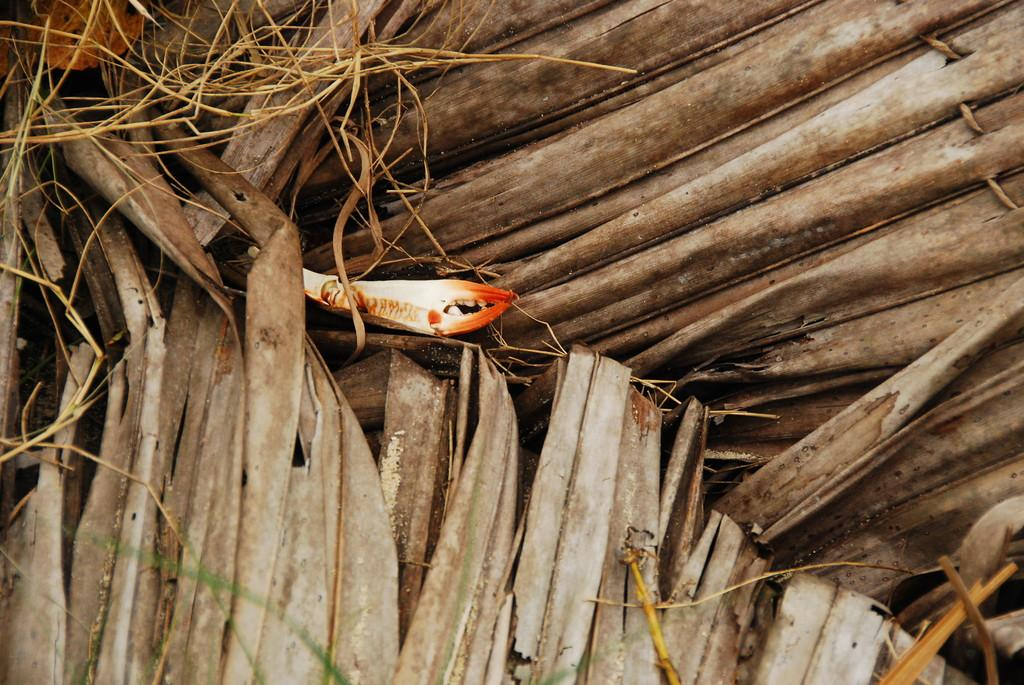What material is used to construct the roof in the image? The roof in the image is made of dry leaves. Can you describe the object located in the middle of the image? There is an orange and white color thing present in the middle of the image. How does the zephyr affect the orange and white color thing in the image? There is no mention of a zephyr in the image, so it cannot be determined how it would affect the orange and white color thing. 